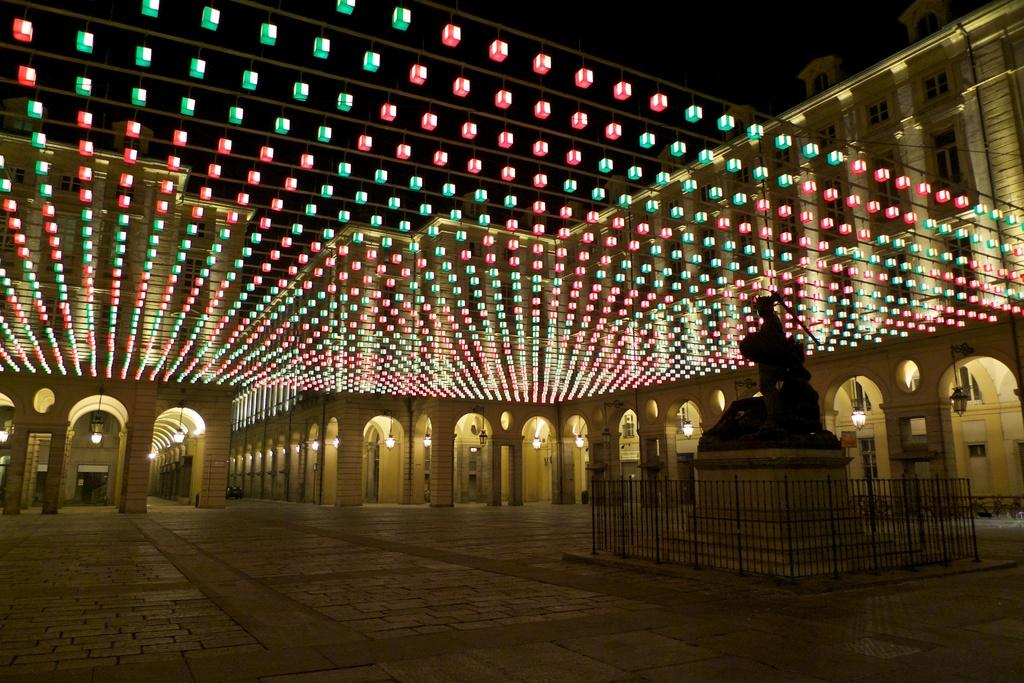What is the main subject in the image? There is a statue in the image. What is around the statue? The statue is surrounded by a fence. What is above the statue? There are lights above the statue. What can be seen in the background of the image? There are buildings with corridors and lights in the background of the image. What type of bottle is being used for learning in the image? There is no bottle or learning activity present in the image. 